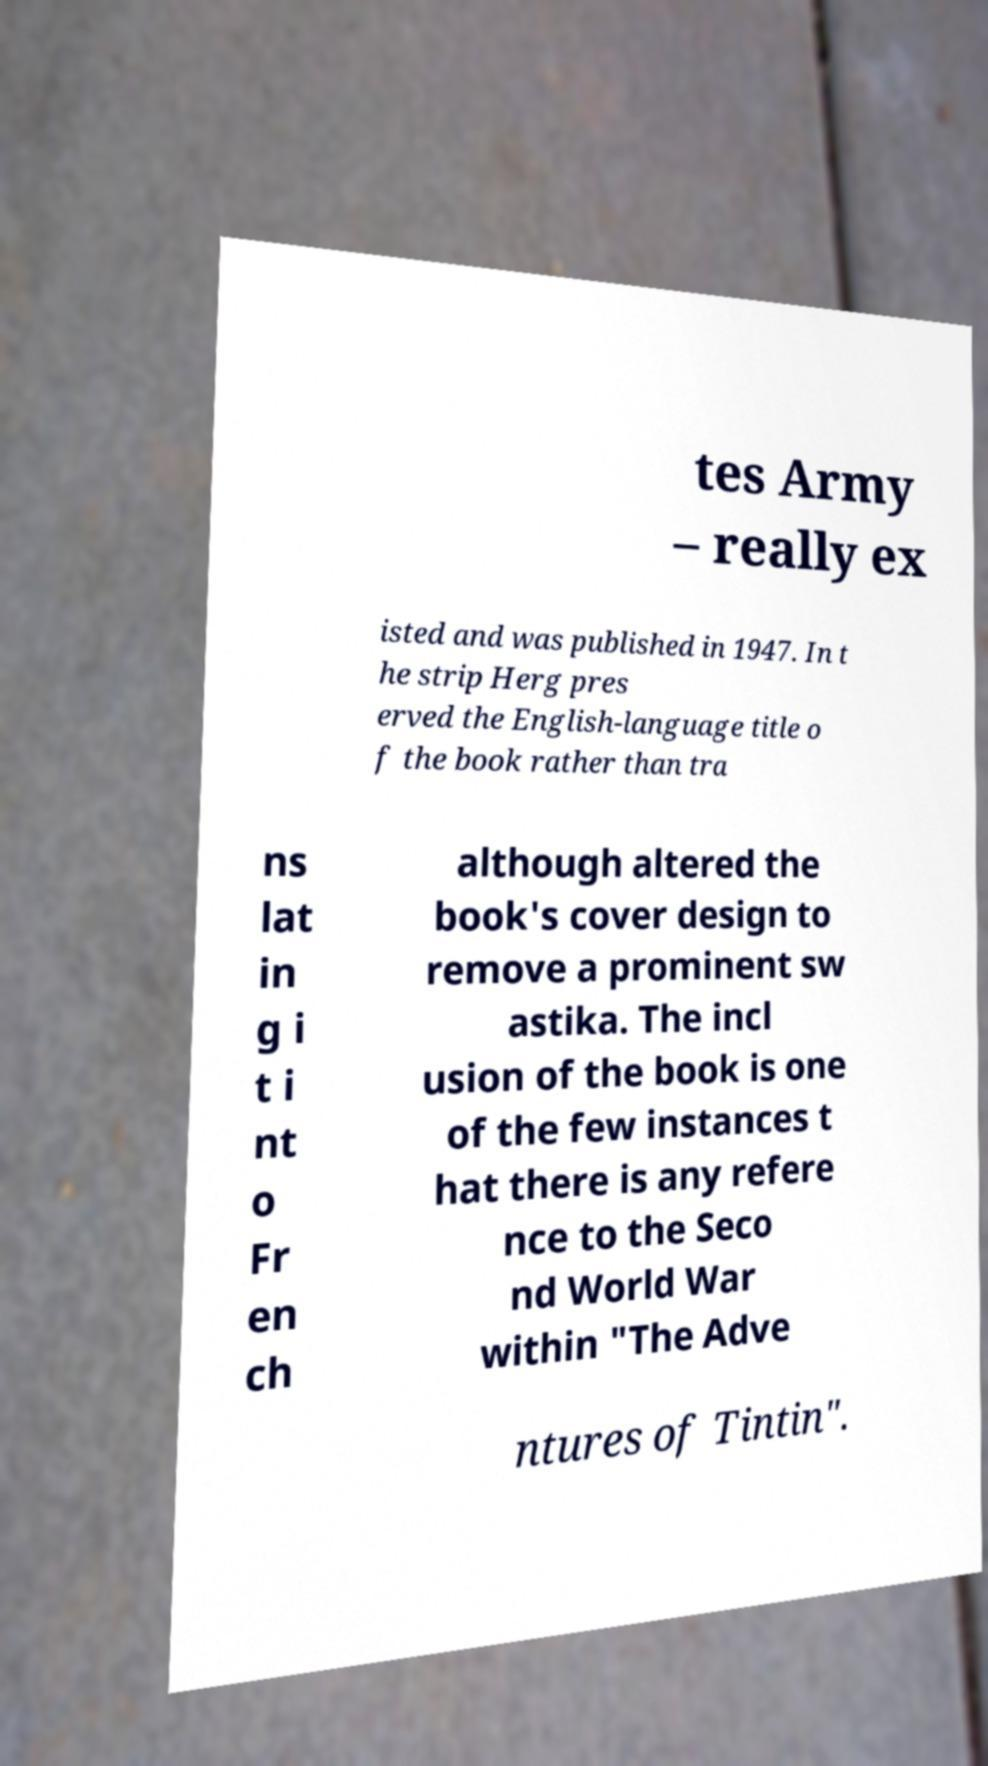I need the written content from this picture converted into text. Can you do that? tes Army – really ex isted and was published in 1947. In t he strip Herg pres erved the English-language title o f the book rather than tra ns lat in g i t i nt o Fr en ch although altered the book's cover design to remove a prominent sw astika. The incl usion of the book is one of the few instances t hat there is any refere nce to the Seco nd World War within "The Adve ntures of Tintin". 